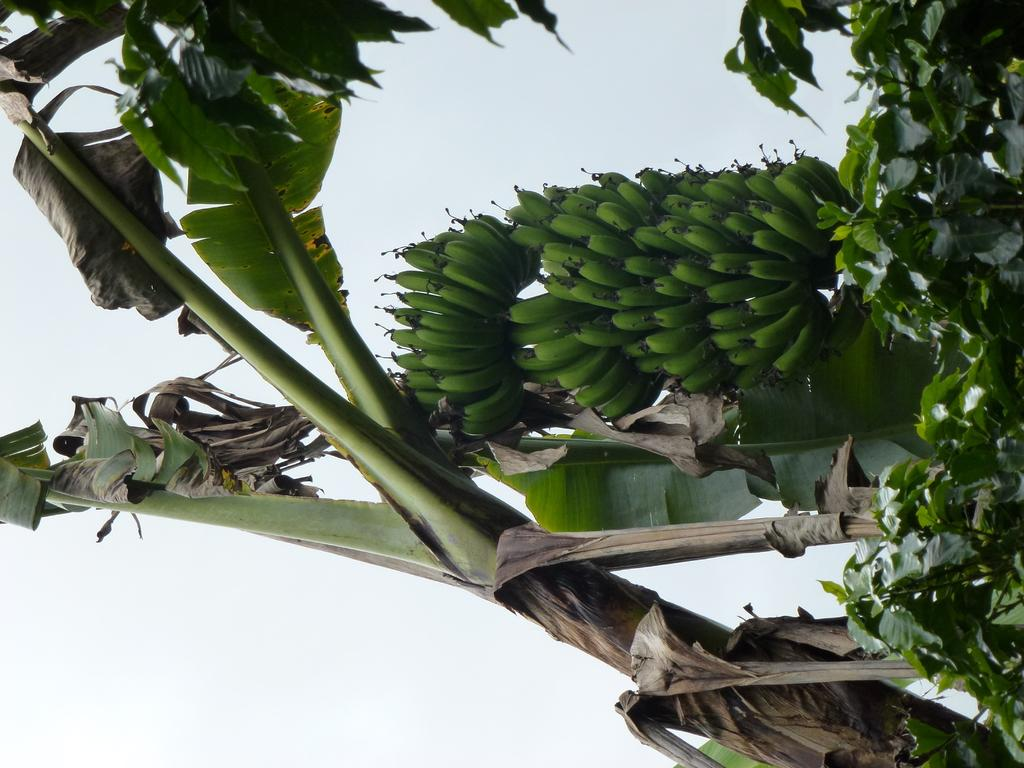What type of fruit is present in the image? There are bananas in the image. What other plant elements can be seen in the image? There are green leaves in the image. What part of the natural environment is visible in the image? The sky is visible in the image. What type of tail can be seen on the bananas in the image? There are no tails present on the bananas in the image. 